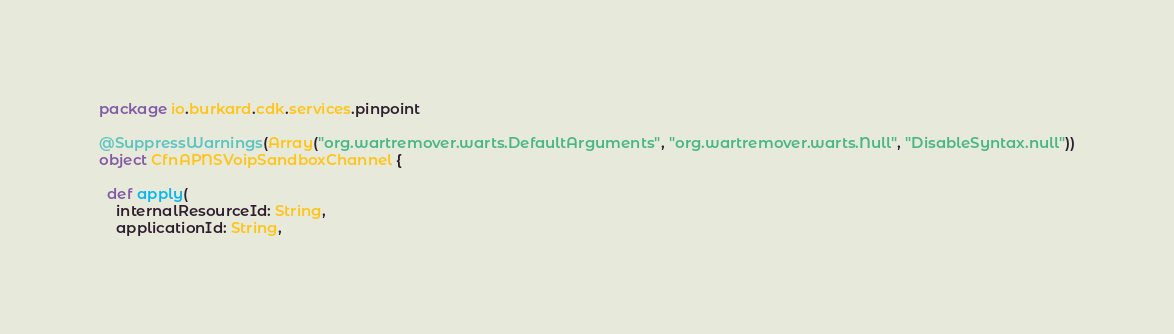Convert code to text. <code><loc_0><loc_0><loc_500><loc_500><_Scala_>package io.burkard.cdk.services.pinpoint

@SuppressWarnings(Array("org.wartremover.warts.DefaultArguments", "org.wartremover.warts.Null", "DisableSyntax.null"))
object CfnAPNSVoipSandboxChannel {

  def apply(
    internalResourceId: String,
    applicationId: String,</code> 